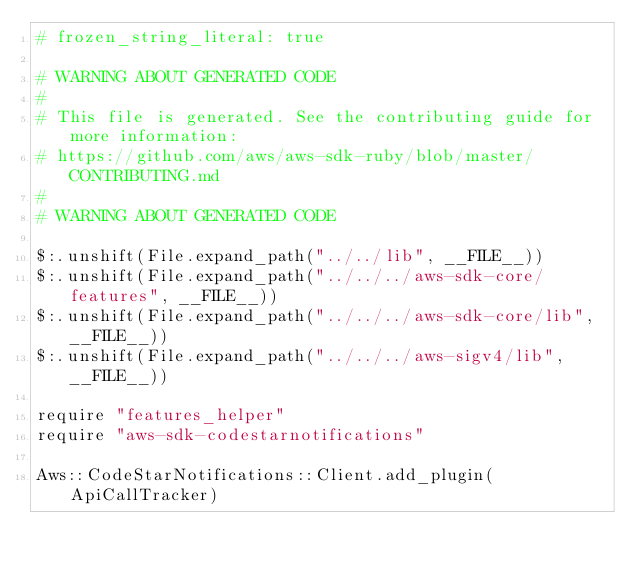<code> <loc_0><loc_0><loc_500><loc_500><_Crystal_># frozen_string_literal: true

# WARNING ABOUT GENERATED CODE
#
# This file is generated. See the contributing guide for more information:
# https://github.com/aws/aws-sdk-ruby/blob/master/CONTRIBUTING.md
#
# WARNING ABOUT GENERATED CODE

$:.unshift(File.expand_path("../../lib", __FILE__))
$:.unshift(File.expand_path("../../../aws-sdk-core/features", __FILE__))
$:.unshift(File.expand_path("../../../aws-sdk-core/lib", __FILE__))
$:.unshift(File.expand_path("../../../aws-sigv4/lib", __FILE__))

require "features_helper"
require "aws-sdk-codestarnotifications"

Aws::CodeStarNotifications::Client.add_plugin(ApiCallTracker)
</code> 